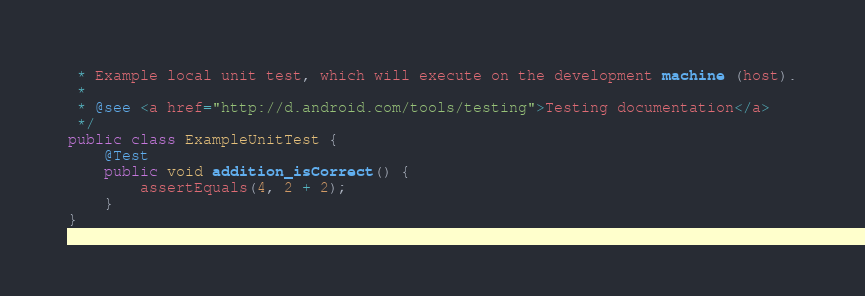Convert code to text. <code><loc_0><loc_0><loc_500><loc_500><_Java_> * Example local unit test, which will execute on the development machine (host).
 *
 * @see <a href="http://d.android.com/tools/testing">Testing documentation</a>
 */
public class ExampleUnitTest {
    @Test
    public void addition_isCorrect() {
        assertEquals(4, 2 + 2);
    }
}</code> 